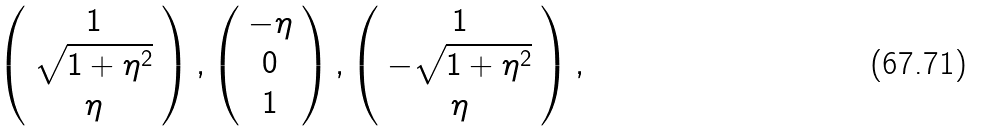Convert formula to latex. <formula><loc_0><loc_0><loc_500><loc_500>\left ( \begin{array} { c } 1 \\ \sqrt { 1 + \eta ^ { 2 } } \\ \eta \end{array} \right ) , \left ( \begin{array} { c } - \eta \\ 0 \\ 1 \end{array} \right ) , \left ( \begin{array} { c } 1 \\ - \sqrt { 1 + \eta ^ { 2 } } \\ \eta \end{array} \right ) ,</formula> 